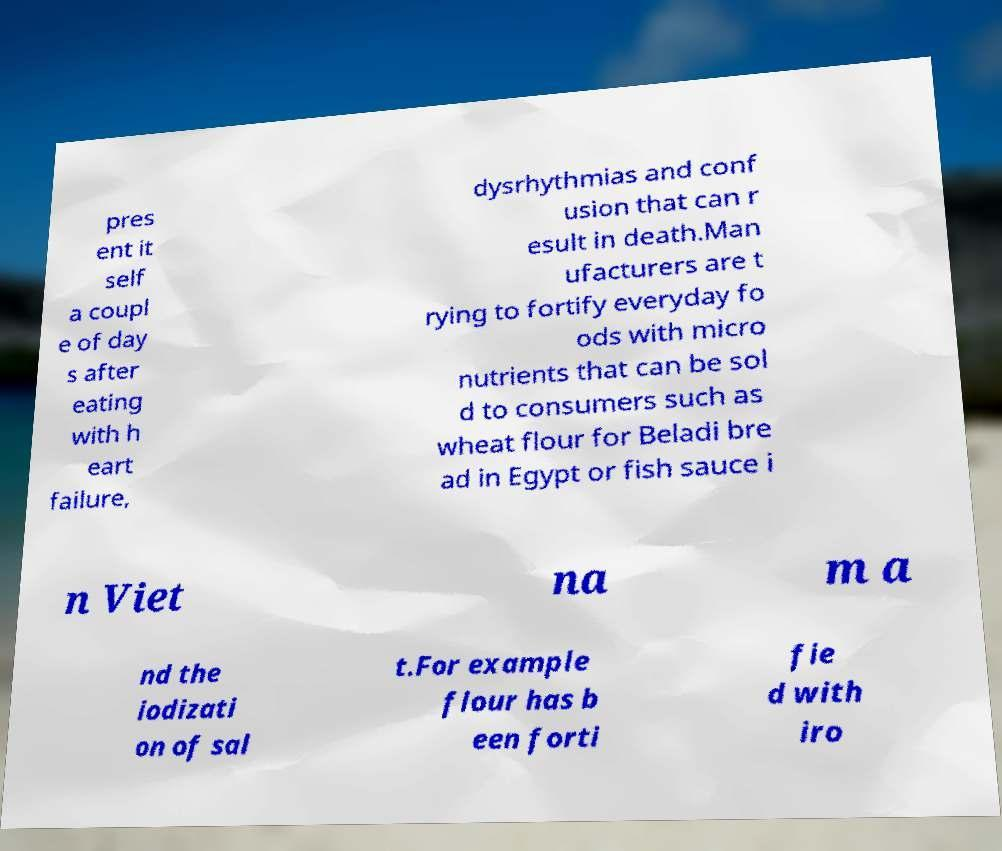Can you accurately transcribe the text from the provided image for me? pres ent it self a coupl e of day s after eating with h eart failure, dysrhythmias and conf usion that can r esult in death.Man ufacturers are t rying to fortify everyday fo ods with micro nutrients that can be sol d to consumers such as wheat flour for Beladi bre ad in Egypt or fish sauce i n Viet na m a nd the iodizati on of sal t.For example flour has b een forti fie d with iro 